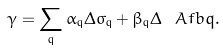Convert formula to latex. <formula><loc_0><loc_0><loc_500><loc_500>\gamma = \sum _ { \mathrm q } \alpha _ { \mathrm q } \Delta \sigma _ { \mathrm q } + \beta _ { \mathrm q } \Delta \ A f b { q } .</formula> 